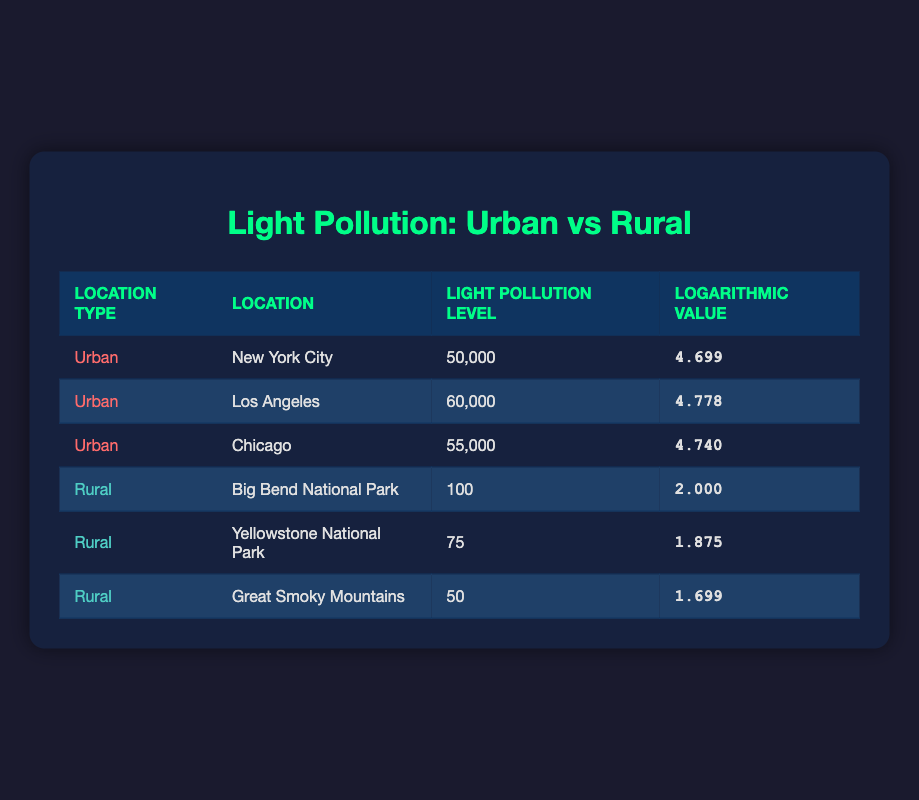What is the light pollution level in Los Angeles? The table shows a row for Los Angeles under the urban category. The light pollution level for Los Angeles is provided as 60,000.
Answer: 60,000 Which city has the highest logarithmic value among urban areas? In the urban section of the table, the logarithmic values are 4.699 for New York City, 4.778 for Los Angeles, and 4.740 for Chicago. Comparing these values, Los Angeles has the highest logarithmic value of 4.778.
Answer: Los Angeles What is the average light pollution level in rural areas? The light pollution levels for rural areas listed in the table are 100, 75, and 50. To calculate the average, first sum these levels: 100 + 75 + 50 = 225. There are 3 data points, so the average is 225 / 3 = 75.
Answer: 75 Is the light pollution level in Big Bend National Park greater than that of Great Smoky Mountains? The table indicates that Big Bend National Park has a light pollution level of 100, whereas Great Smoky Mountains has a level of 50. Since 100 is greater than 50, the statement is true.
Answer: Yes What is the difference in logarithmic values between Los Angeles and Yellowstone National Park? The logarithmic value for Los Angeles is 4.778, and for Yellowstone National Park, it is 1.875. To find the difference, subtract the value of Yellowstone from that of Los Angeles: 4.778 - 1.875 = 2.903.
Answer: 2.903 